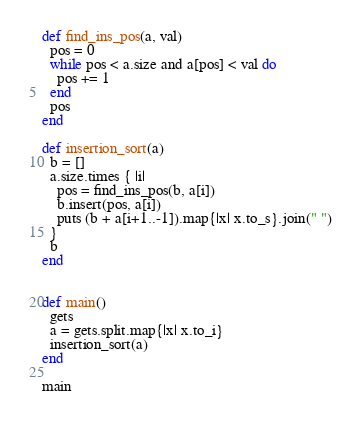Convert code to text. <code><loc_0><loc_0><loc_500><loc_500><_Ruby_>def find_ins_pos(a, val)
  pos = 0
  while pos < a.size and a[pos] < val do
    pos += 1
  end
  pos
end

def insertion_sort(a)
  b = []
  a.size.times { |i|
    pos = find_ins_pos(b, a[i])
    b.insert(pos, a[i])
    puts (b + a[i+1..-1]).map{|x| x.to_s}.join(" ")
  }
  b
end


def main()
  gets
  a = gets.split.map{|x| x.to_i}
  insertion_sort(a)
end

main

</code> 